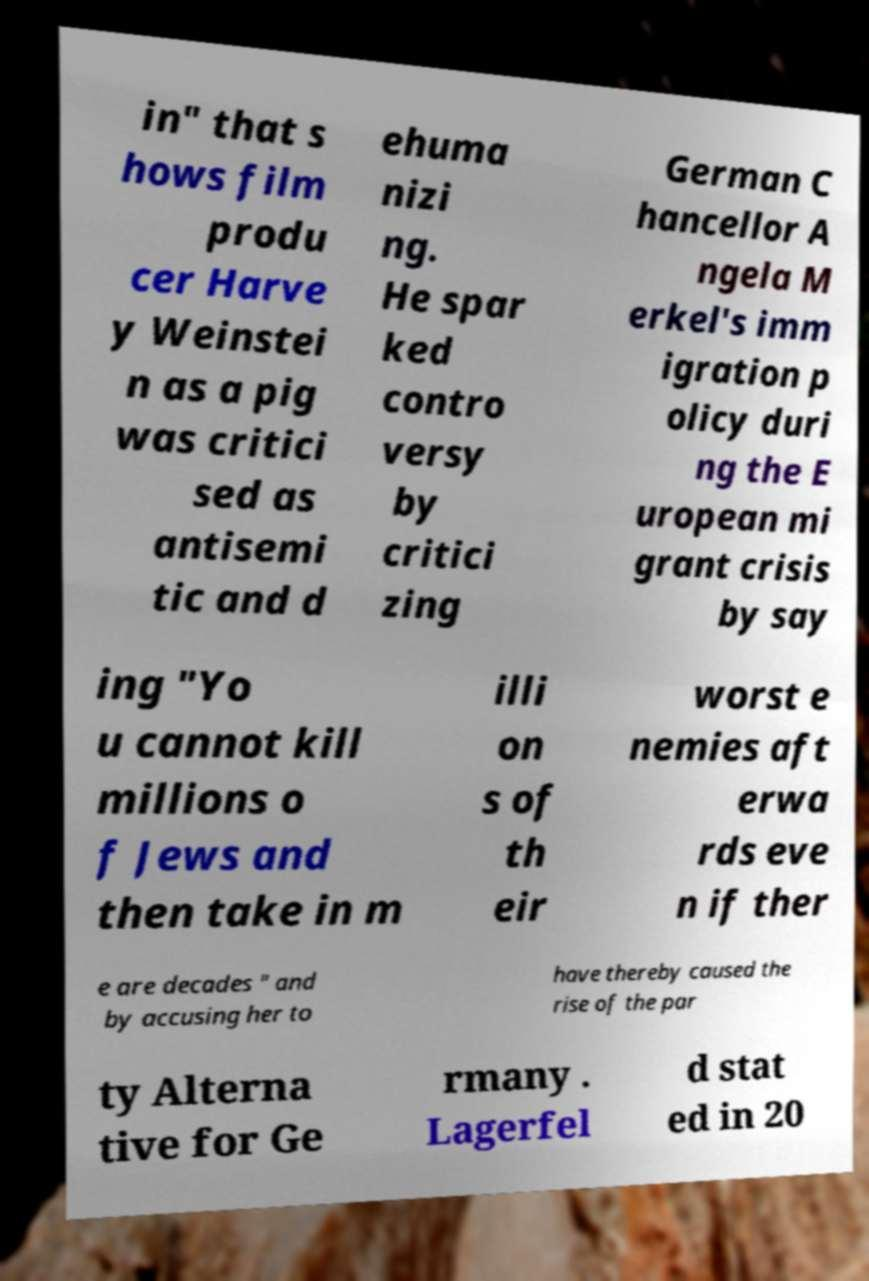What messages or text are displayed in this image? I need them in a readable, typed format. in" that s hows film produ cer Harve y Weinstei n as a pig was critici sed as antisemi tic and d ehuma nizi ng. He spar ked contro versy by critici zing German C hancellor A ngela M erkel's imm igration p olicy duri ng the E uropean mi grant crisis by say ing "Yo u cannot kill millions o f Jews and then take in m illi on s of th eir worst e nemies aft erwa rds eve n if ther e are decades " and by accusing her to have thereby caused the rise of the par ty Alterna tive for Ge rmany . Lagerfel d stat ed in 20 